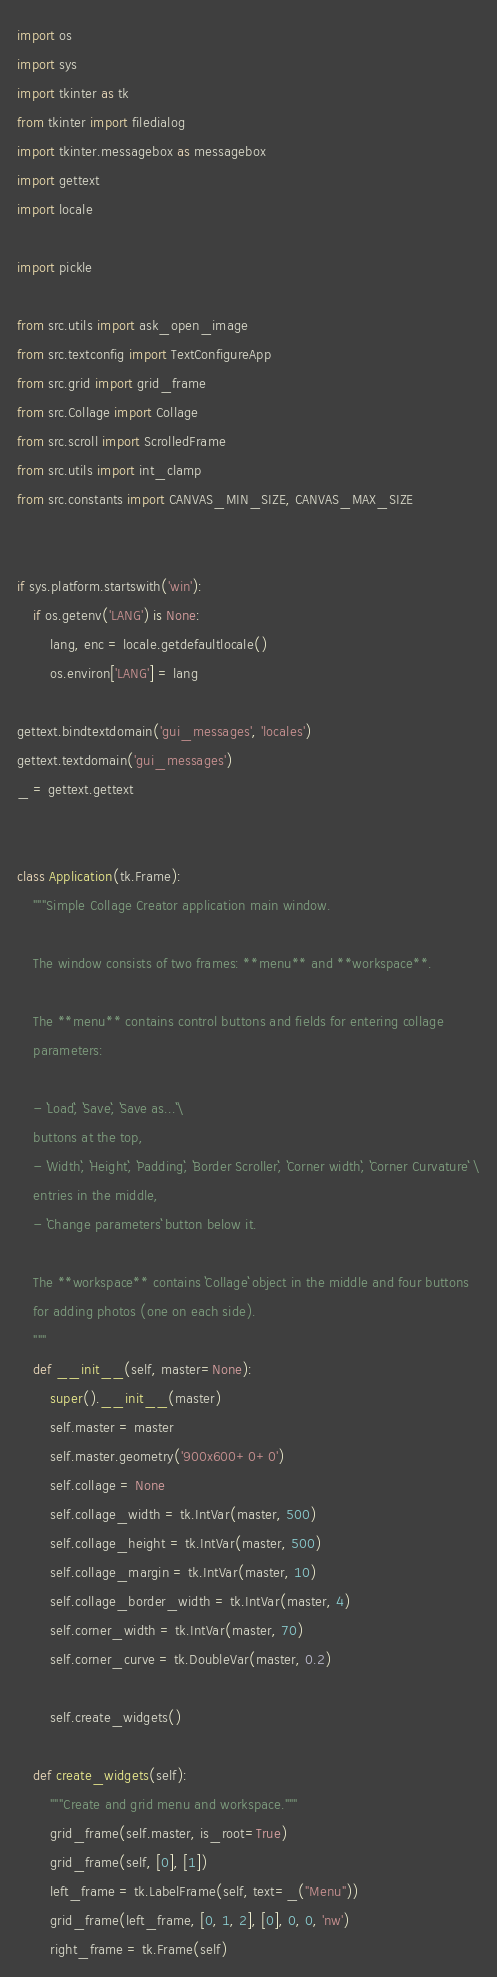Convert code to text. <code><loc_0><loc_0><loc_500><loc_500><_Python_>import os
import sys
import tkinter as tk
from tkinter import filedialog
import tkinter.messagebox as messagebox
import gettext
import locale

import pickle

from src.utils import ask_open_image
from src.textconfig import TextConfigureApp
from src.grid import grid_frame
from src.Collage import Collage
from src.scroll import ScrolledFrame
from src.utils import int_clamp
from src.constants import CANVAS_MIN_SIZE, CANVAS_MAX_SIZE


if sys.platform.startswith('win'):
    if os.getenv('LANG') is None:
        lang, enc = locale.getdefaultlocale()
        os.environ['LANG'] = lang

gettext.bindtextdomain('gui_messages', 'locales')
gettext.textdomain('gui_messages')
_ = gettext.gettext


class Application(tk.Frame):
    """Simple Collage Creator application main window.

    The window consists of two frames: **menu** and **workspace**.

    The **menu** contains control buttons and fields for entering collage
    parameters:

    - ``Load``, ``Save``, ``Save as...``\
    buttons at the top,
    - ``Width``, ``Height``, ``Padding``, ``Border Scroller``, ``Corner width``, ``Corner Curvature`` \
    entries in the middle,
    - ``Change parameters`` button below it.

    The **workspace** contains ``Collage`` object in the middle and four buttons
    for adding photos (one on each side).
    """
    def __init__(self, master=None):
        super().__init__(master)
        self.master = master
        self.master.geometry('900x600+0+0')
        self.collage = None
        self.collage_width = tk.IntVar(master, 500)
        self.collage_height = tk.IntVar(master, 500)
        self.collage_margin = tk.IntVar(master, 10)
        self.collage_border_width = tk.IntVar(master, 4)
        self.corner_width = tk.IntVar(master, 70)
        self.corner_curve = tk.DoubleVar(master, 0.2)

        self.create_widgets()

    def create_widgets(self):
        """Create and grid menu and workspace."""
        grid_frame(self.master, is_root=True)
        grid_frame(self, [0], [1])
        left_frame = tk.LabelFrame(self, text=_("Menu"))
        grid_frame(left_frame, [0, 1, 2], [0], 0, 0, 'nw')
        right_frame = tk.Frame(self)</code> 